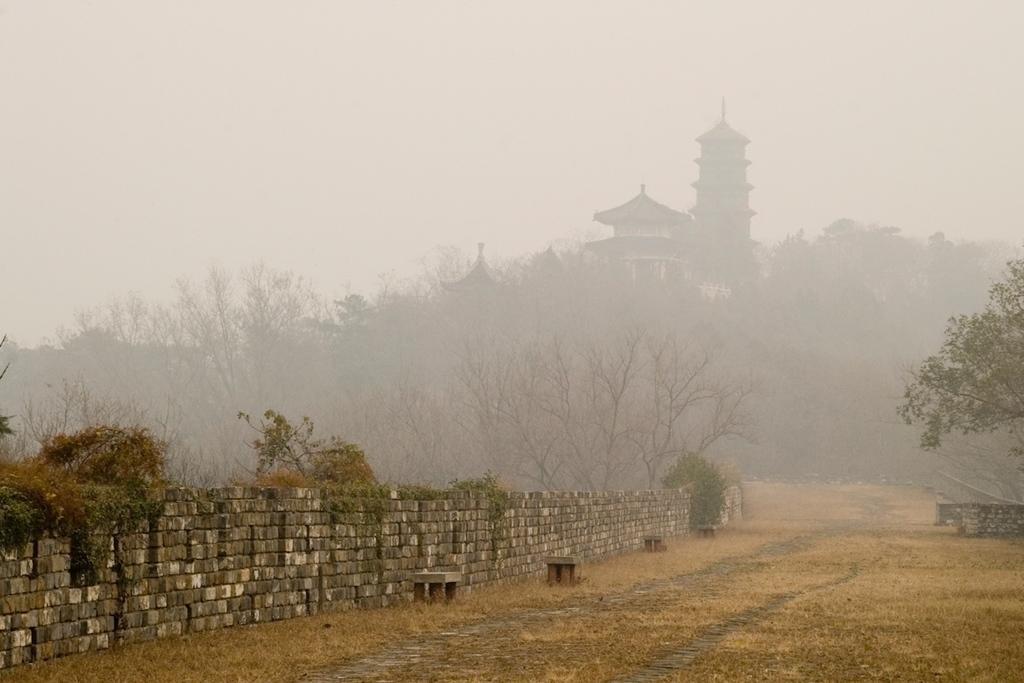What type of structure can be seen in the image? There is a wall in the image. What natural elements are present in the image? There are trees in the image. What type of man-made structures can be seen in the image? There are buildings in the image. What type of bone can be seen in the image? There is no bone present in the image. What taste can be experienced from the trees in the image? Trees do not have a taste, and there is no indication of tasting anything in the image. 